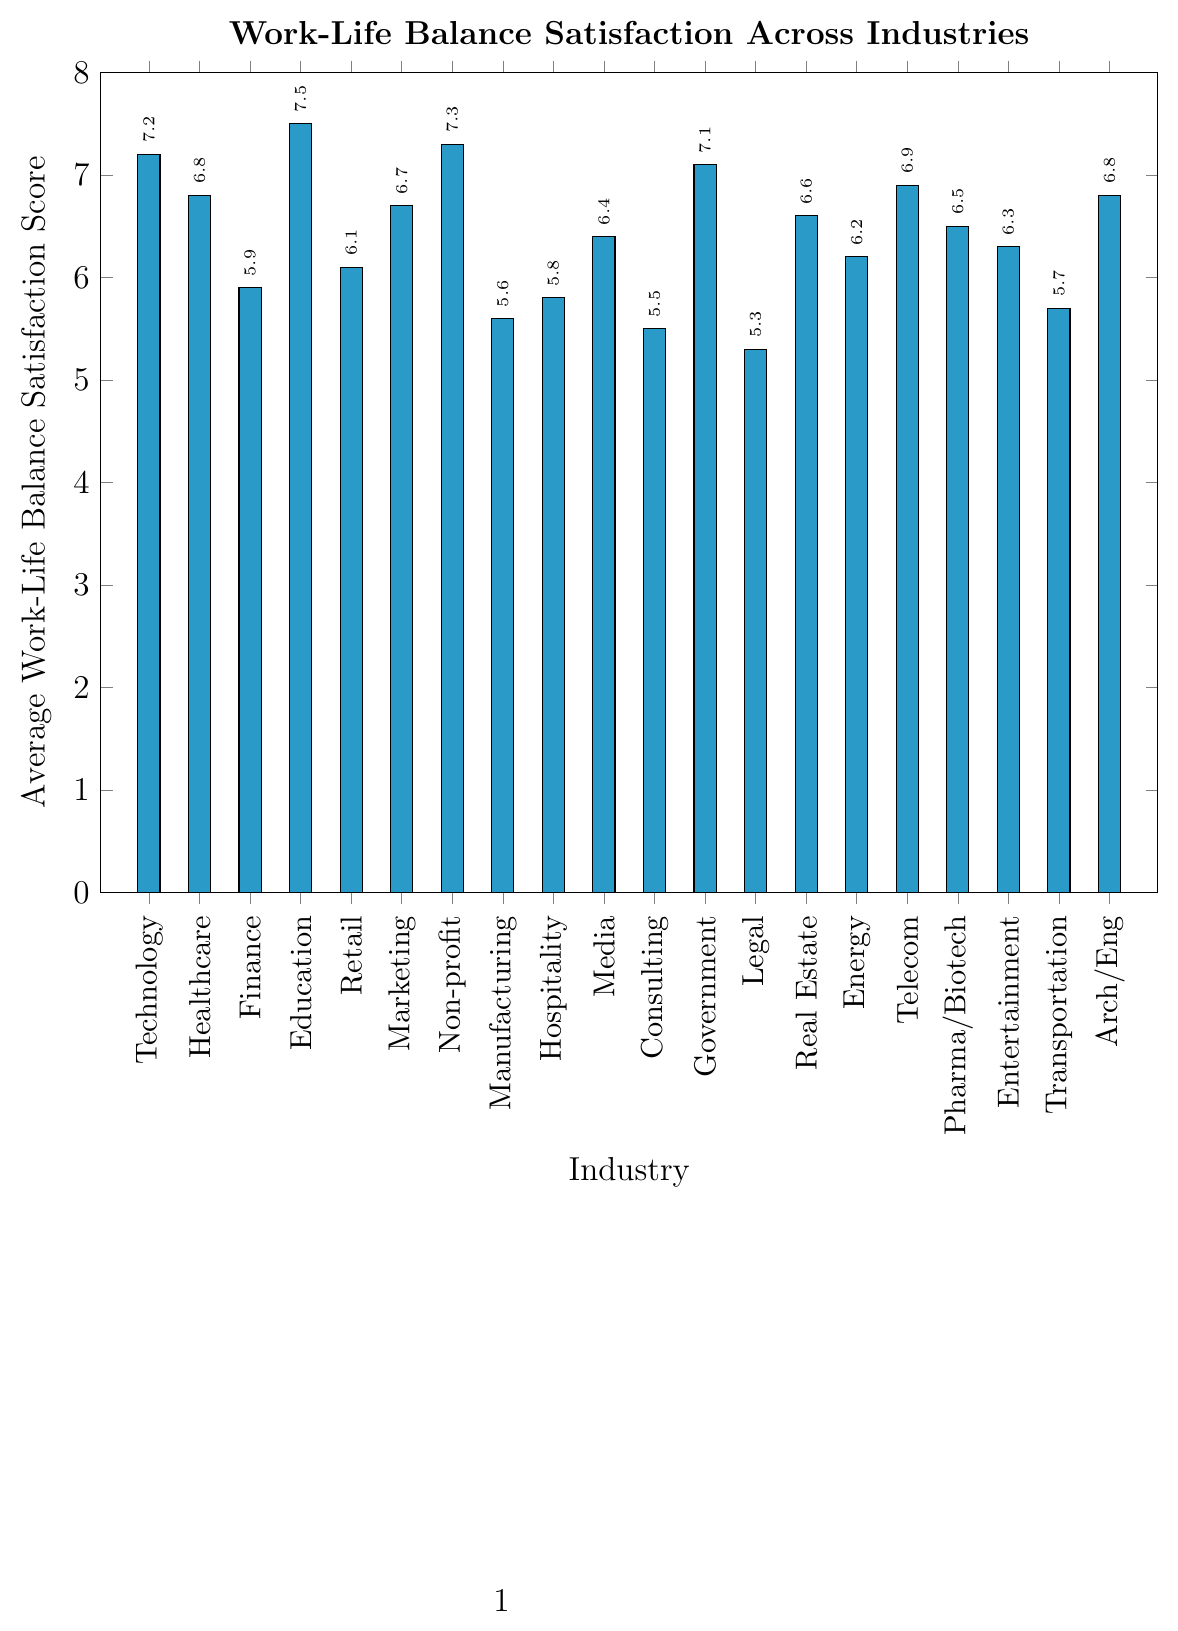Which industry has the highest work-life balance satisfaction score? Identify the tallest bar in the chart and look at the x-axis label corresponding to it.
Answer: Education Which two industries have the lowest satisfaction scores? Identify the two shortest bars in the chart and refer to their respective x-axis labels.
Answer: Legal and Consulting What is the difference between the highest and lowest satisfaction scores? Find the highest value (7.5 for Education) and the lowest value (5.3 for Legal), then subtract the lowest from the highest, 7.5 - 5.3.
Answer: 2.2 Which industry has a higher satisfaction score: Healthcare or Finance? Compare the height of the bar for Healthcare (6.8) with the bar for Finance (5.9).
Answer: Healthcare Which industry has an average satisfaction score of exactly 7.3? Look for the bar with a height of 7.3 and read the corresponding x-axis label.
Answer: Non-profit Which industries have satisfaction scores greater than 7? Identify all bars with heights greater than 7 and read their corresponding x-axis labels.
Answer: Technology, Education, Non-profit, Government What is the total sum of satisfaction scores for Technology, Retail, and Media industries? Find the satisfaction scores for each of the mentioned industries and sum them: Technology (7.2), Retail (6.1), Media (6.4). The calculation is 7.2 + 6.1 + 6.4.
Answer: 19.7 Which industry has a satisfaction score closest to 6.5? Find the bars with values around 6.5 and identify the one closest to 6.5, which is directly 6.5.
Answer: Pharma/Biotech What is the median satisfaction score of all industries? List all satisfaction scores: 7.2, 6.8, 5.9, 7.5, 6.1, 6.7, 7.3, 5.6, 5.8, 6.4, 5.5, 7.1, 5.3, 6.6, 6.2, 6.9, 6.5, 6.3, 5.7, 6.8. Arrange them in ascending order and find the middle value (when the values are sorted, the middle values are 6.6 and 6.7, median is the average of those).
Answer: 6.65 What is the average satisfaction score across all industries? Sum all the satisfaction scores and divide by the total number of industries. The sum is 125.6, and there are 20 industries. So, the average is 125.6 / 20.
Answer: 6.28 